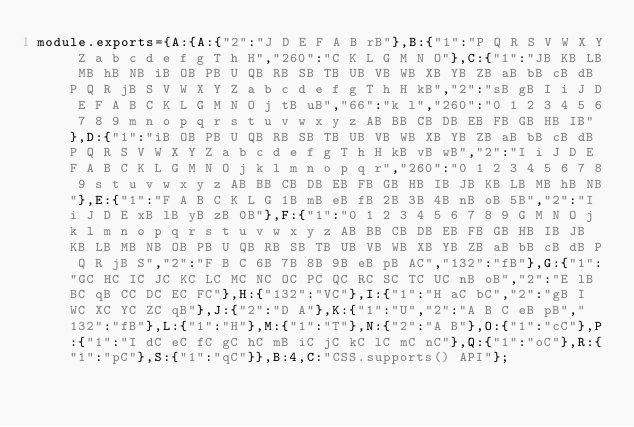Convert code to text. <code><loc_0><loc_0><loc_500><loc_500><_JavaScript_>module.exports={A:{A:{"2":"J D E F A B rB"},B:{"1":"P Q R S V W X Y Z a b c d e f g T h H","260":"C K L G M N O"},C:{"1":"JB KB LB MB hB NB iB OB PB U QB RB SB TB UB VB WB XB YB ZB aB bB cB dB P Q R jB S V W X Y Z a b c d e f g T h H kB","2":"sB gB I i J D E F A B C K L G M N O j tB uB","66":"k l","260":"0 1 2 3 4 5 6 7 8 9 m n o p q r s t u v w x y z AB BB CB DB EB FB GB HB IB"},D:{"1":"iB OB PB U QB RB SB TB UB VB WB XB YB ZB aB bB cB dB P Q R S V W X Y Z a b c d e f g T h H kB vB wB","2":"I i J D E F A B C K L G M N O j k l m n o p q r","260":"0 1 2 3 4 5 6 7 8 9 s t u v w x y z AB BB CB DB EB FB GB HB IB JB KB LB MB hB NB"},E:{"1":"F A B C K L G 1B mB eB fB 2B 3B 4B nB oB 5B","2":"I i J D E xB lB yB zB 0B"},F:{"1":"0 1 2 3 4 5 6 7 8 9 G M N O j k l m n o p q r s t u v w x y z AB BB CB DB EB FB GB HB IB JB KB LB MB NB OB PB U QB RB SB TB UB VB WB XB YB ZB aB bB cB dB P Q R jB S","2":"F B C 6B 7B 8B 9B eB pB AC","132":"fB"},G:{"1":"GC HC IC JC KC LC MC NC OC PC QC RC SC TC UC nB oB","2":"E lB BC qB CC DC EC FC"},H:{"132":"VC"},I:{"1":"H aC bC","2":"gB I WC XC YC ZC qB"},J:{"2":"D A"},K:{"1":"U","2":"A B C eB pB","132":"fB"},L:{"1":"H"},M:{"1":"T"},N:{"2":"A B"},O:{"1":"cC"},P:{"1":"I dC eC fC gC hC mB iC jC kC lC mC nC"},Q:{"1":"oC"},R:{"1":"pC"},S:{"1":"qC"}},B:4,C:"CSS.supports() API"};
</code> 